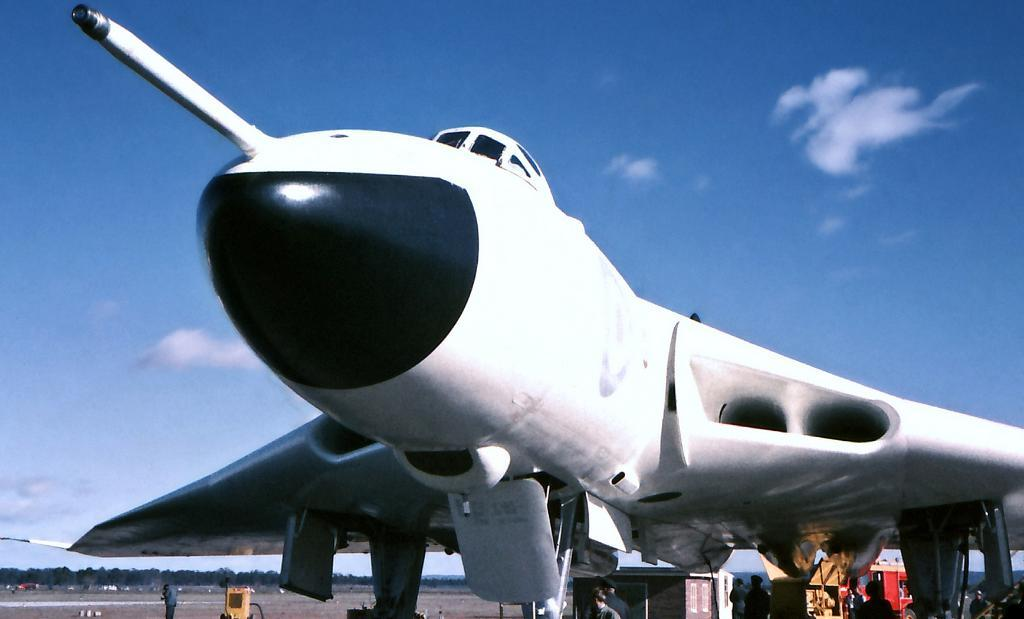What is the main subject of the picture? The main subject of the picture is an airplane. What can be seen near the airplane? There are people standing near the airplane. What other structures are present in the image? There is a building and a vehicle in the picture. What type of vegetation is visible in the image? There are trees in the picture. How would you describe the sky in the image? The sky is blue and cloudy. Can you hear the yak making noise in the image? There is no yak present in the image, so it is not possible to hear any noise from a yak. 